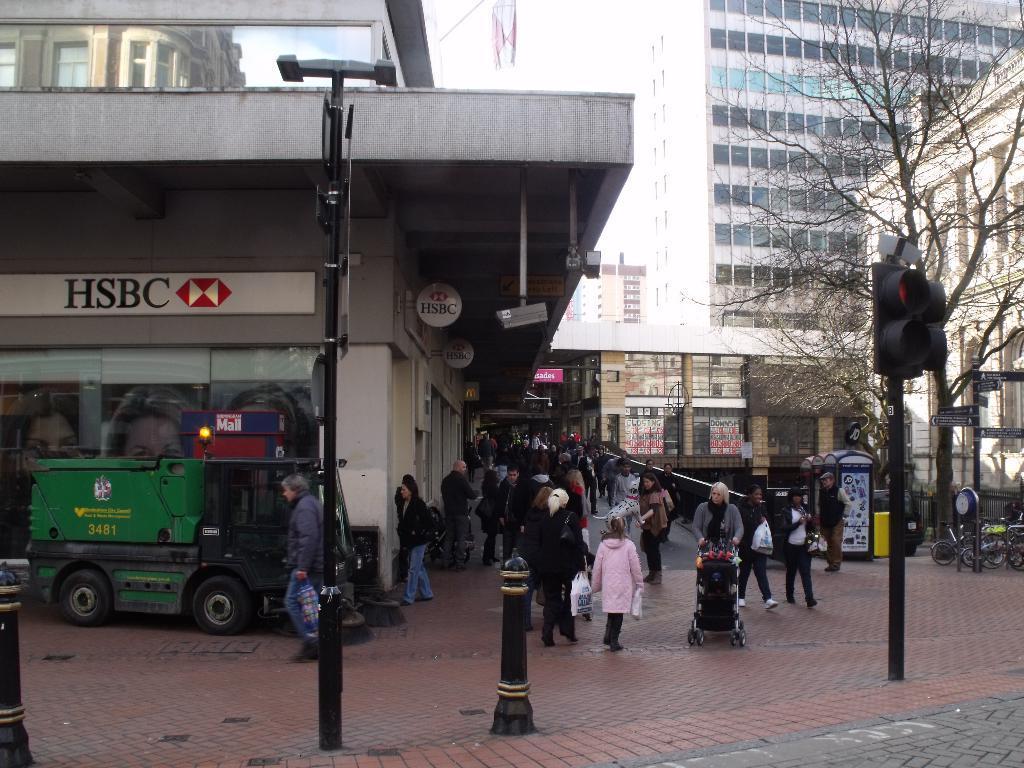Describe this image in one or two sentences. There is a crowd at the bottom of this image we can see a vehicle on the left side of this image. We can see trees and signal lights on the right side of this image. 